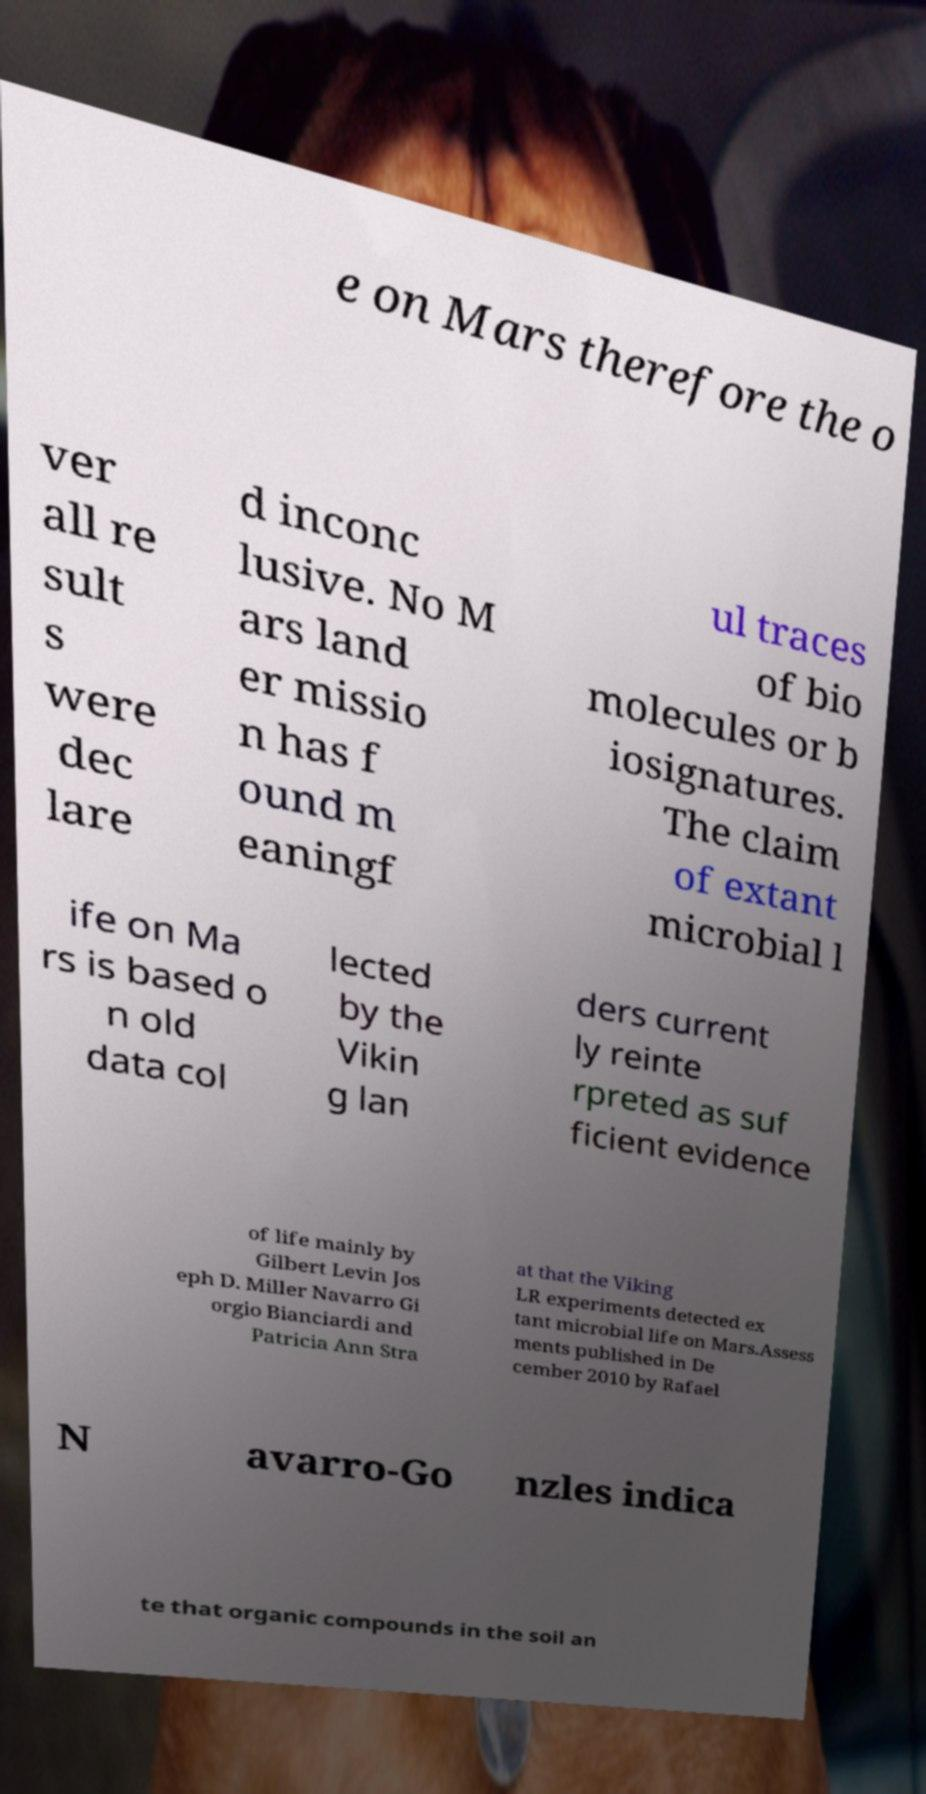Please read and relay the text visible in this image. What does it say? e on Mars therefore the o ver all re sult s were dec lare d inconc lusive. No M ars land er missio n has f ound m eaningf ul traces of bio molecules or b iosignatures. The claim of extant microbial l ife on Ma rs is based o n old data col lected by the Vikin g lan ders current ly reinte rpreted as suf ficient evidence of life mainly by Gilbert Levin Jos eph D. Miller Navarro Gi orgio Bianciardi and Patricia Ann Stra at that the Viking LR experiments detected ex tant microbial life on Mars.Assess ments published in De cember 2010 by Rafael N avarro-Go nzles indica te that organic compounds in the soil an 